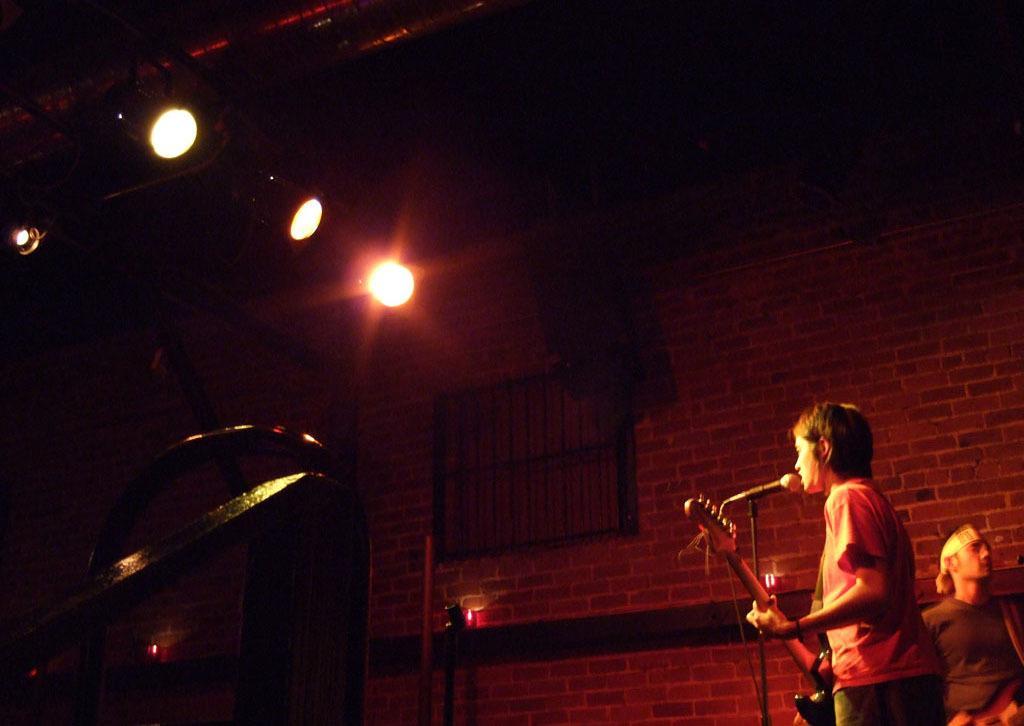Please provide a concise description of this image. In this image on the right, there is a man, he wears a t shirt, trouser, he is playing guitar, in front of him there is a mic and there is a man, he wears a t shirt, guitar. In the middle there are lights, window, wall and roof. 